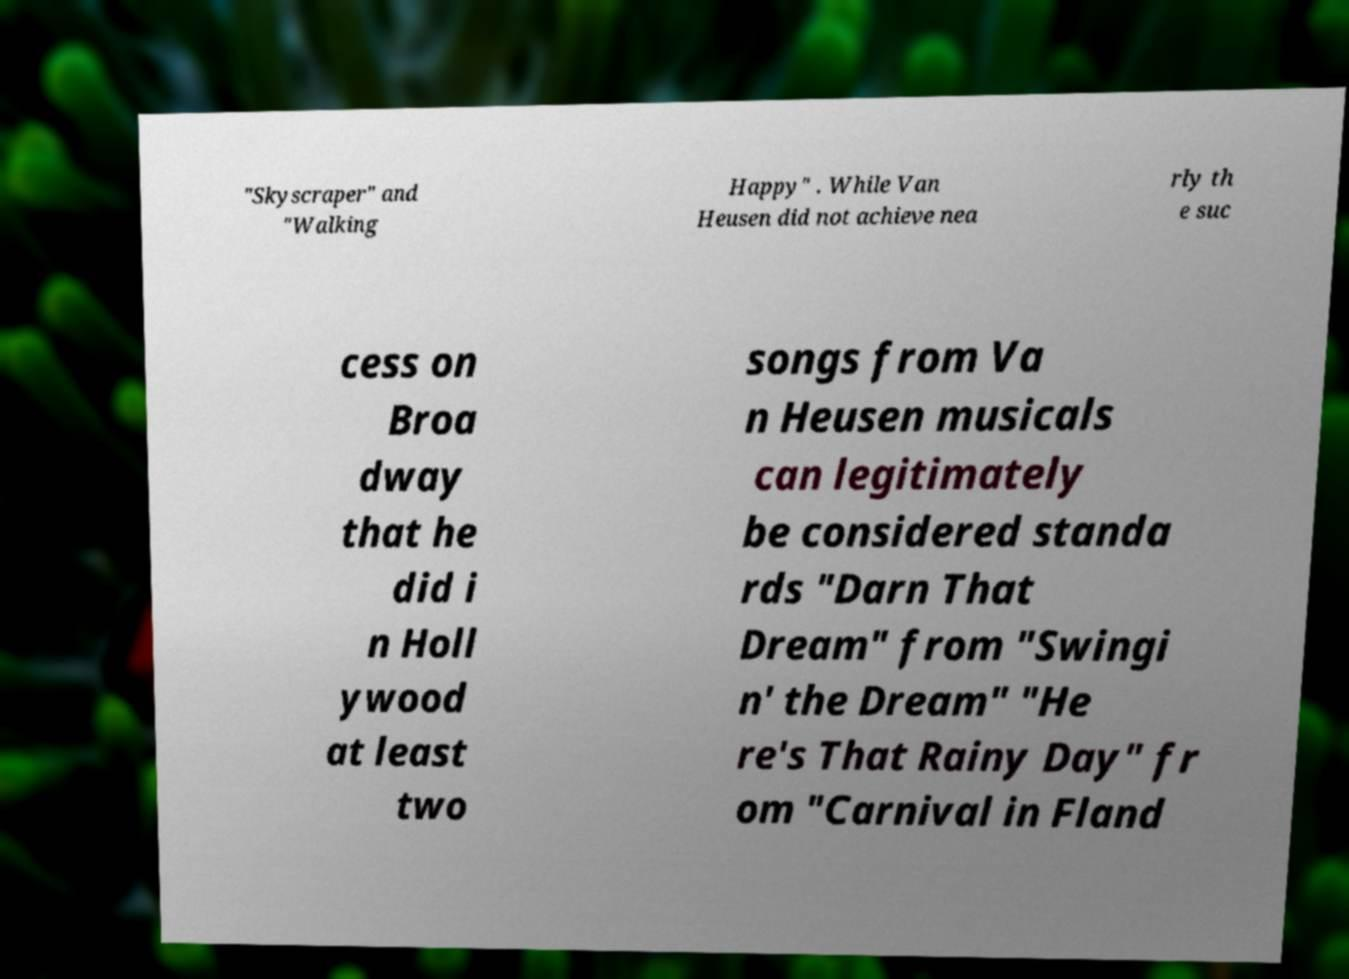Can you accurately transcribe the text from the provided image for me? "Skyscraper" and "Walking Happy" . While Van Heusen did not achieve nea rly th e suc cess on Broa dway that he did i n Holl ywood at least two songs from Va n Heusen musicals can legitimately be considered standa rds "Darn That Dream" from "Swingi n' the Dream" "He re's That Rainy Day" fr om "Carnival in Fland 